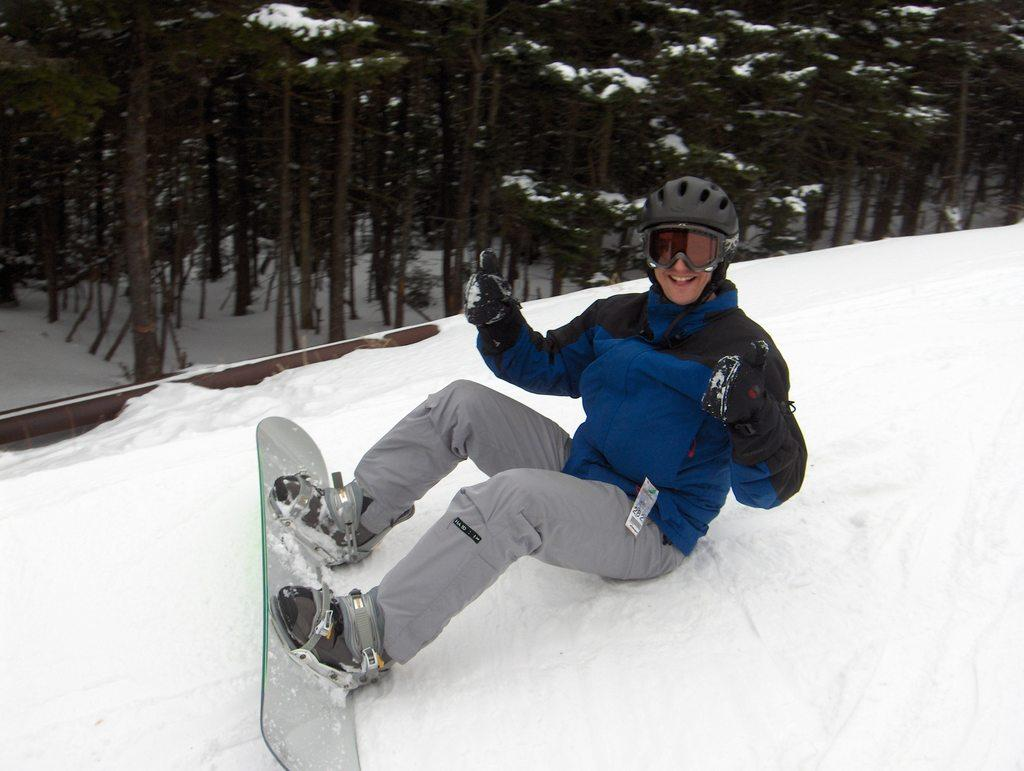What is the main subject of the image? There is a person in the image. What activity is the person engaged in? The person is on a ski board. What protective gear is the person wearing? The person is wearing a black color helmet. What other clothing item can be seen on the person? The person is wearing gloves. What is the color of the snow in the image? There is white color snow in the image. What can be seen in the background of the image? There are trees in the background of the image. How many rabbits are hopping around the person in the image? There are no rabbits present in the image. What type of glass is the person holding in the image? There is no glass present in the image. 